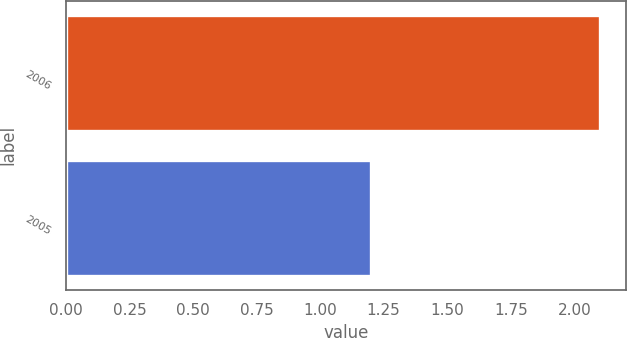Convert chart. <chart><loc_0><loc_0><loc_500><loc_500><bar_chart><fcel>2006<fcel>2005<nl><fcel>2.1<fcel>1.2<nl></chart> 